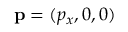Convert formula to latex. <formula><loc_0><loc_0><loc_500><loc_500>{ p } = ( p _ { x } , 0 , 0 )</formula> 